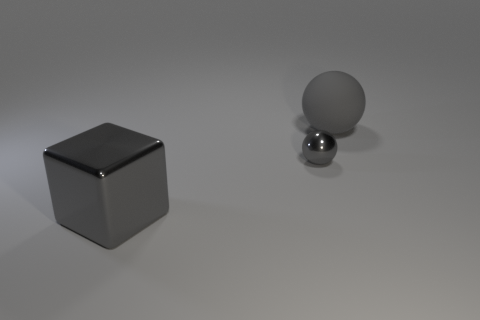Subtract all balls. How many objects are left? 1 Subtract 0 purple cylinders. How many objects are left? 3 Subtract 1 blocks. How many blocks are left? 0 Subtract all green blocks. Subtract all green balls. How many blocks are left? 1 Subtract all blocks. Subtract all tiny gray objects. How many objects are left? 1 Add 3 large gray matte spheres. How many large gray matte spheres are left? 4 Add 3 tiny brown cylinders. How many tiny brown cylinders exist? 3 Add 1 brown matte objects. How many objects exist? 4 